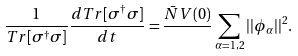<formula> <loc_0><loc_0><loc_500><loc_500>\frac { 1 } { T r [ \sigma ^ { \dagger } \sigma ] } \frac { d T r [ \sigma ^ { \dagger } \sigma ] } { d t } = \frac { \bar { N } V ( 0 ) } { } \sum _ { \alpha = 1 , 2 } | | \phi _ { \alpha } | | ^ { 2 } .</formula> 